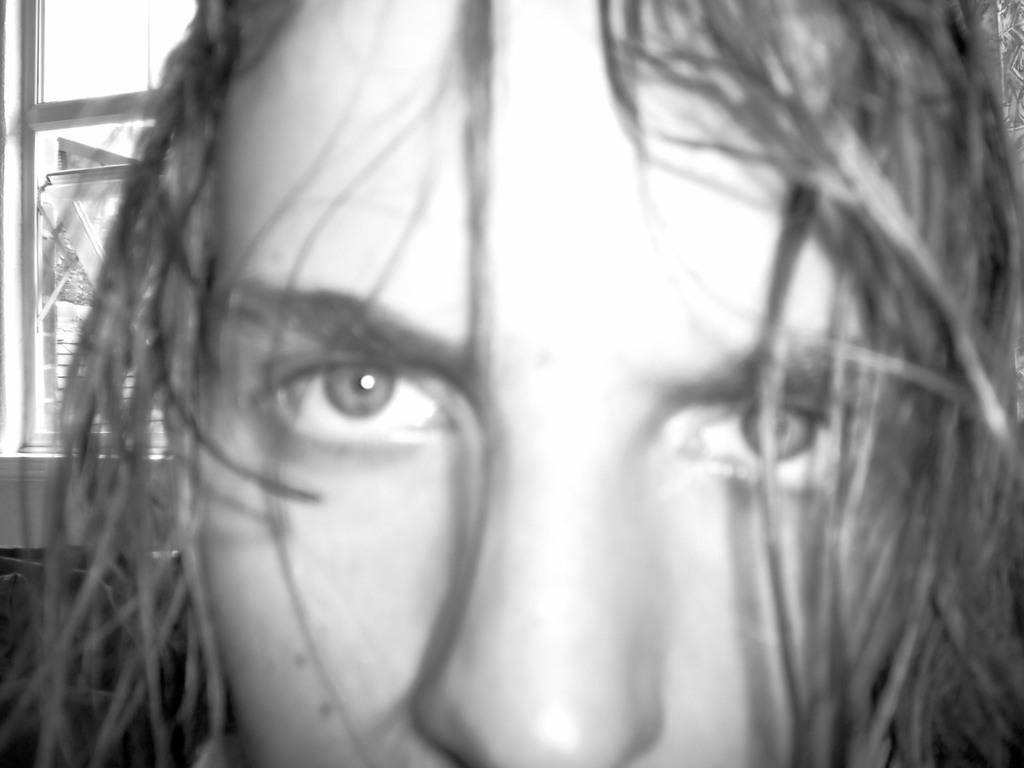What can be seen in the image regarding a human figure? There is a person in the image, and the backside of the person is visible. What type of architectural feature is present in the image? There is a glass window in the image. What natural element is present in the image? There is a tree in the image. What objects are placed on a surface in the image? There are objects on a surface in the image. What type of beef is being cooked on the tree in the image? There is no beef or cooking activity present in the image; it features a person, a glass window, a tree, and objects on a surface. 